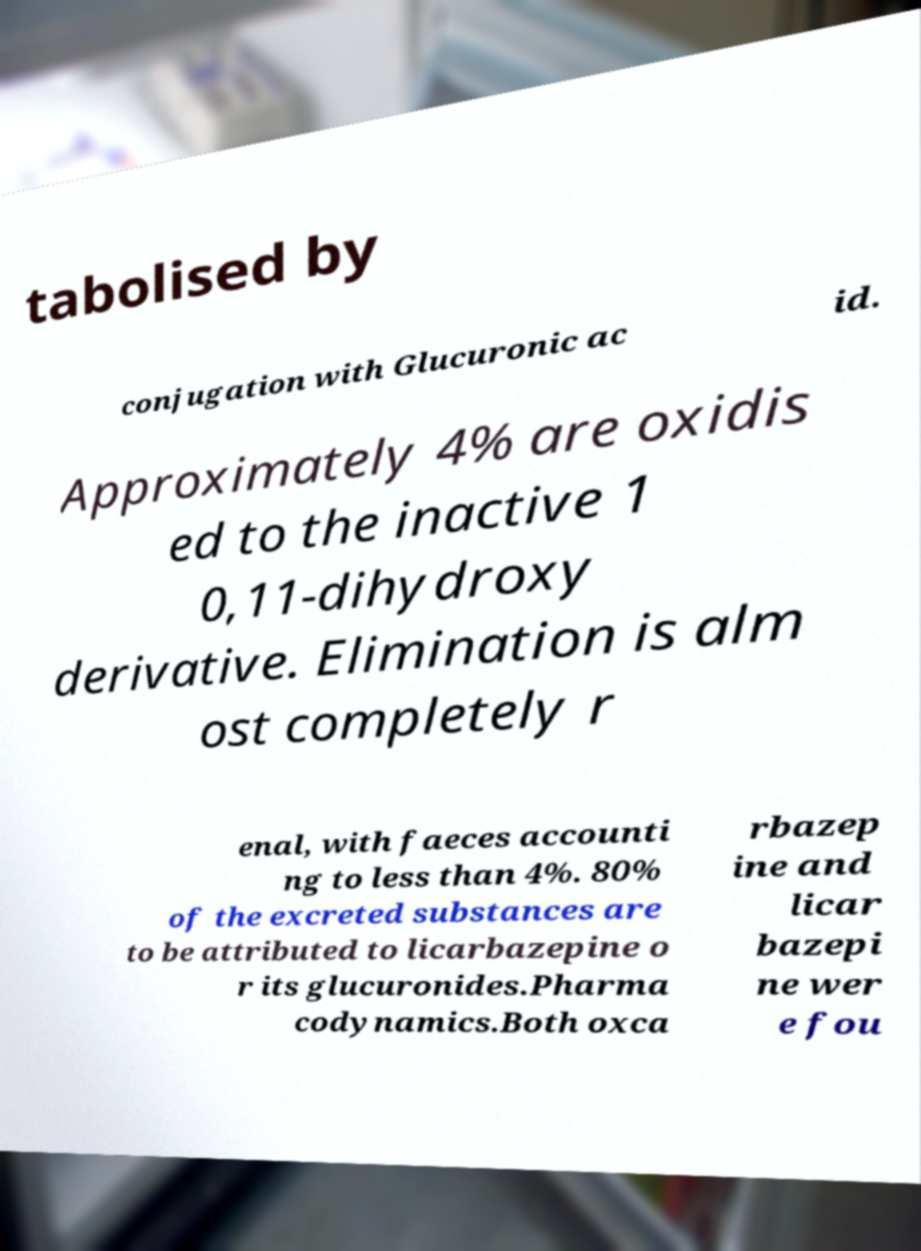Please read and relay the text visible in this image. What does it say? tabolised by conjugation with Glucuronic ac id. Approximately 4% are oxidis ed to the inactive 1 0,11-dihydroxy derivative. Elimination is alm ost completely r enal, with faeces accounti ng to less than 4%. 80% of the excreted substances are to be attributed to licarbazepine o r its glucuronides.Pharma codynamics.Both oxca rbazep ine and licar bazepi ne wer e fou 